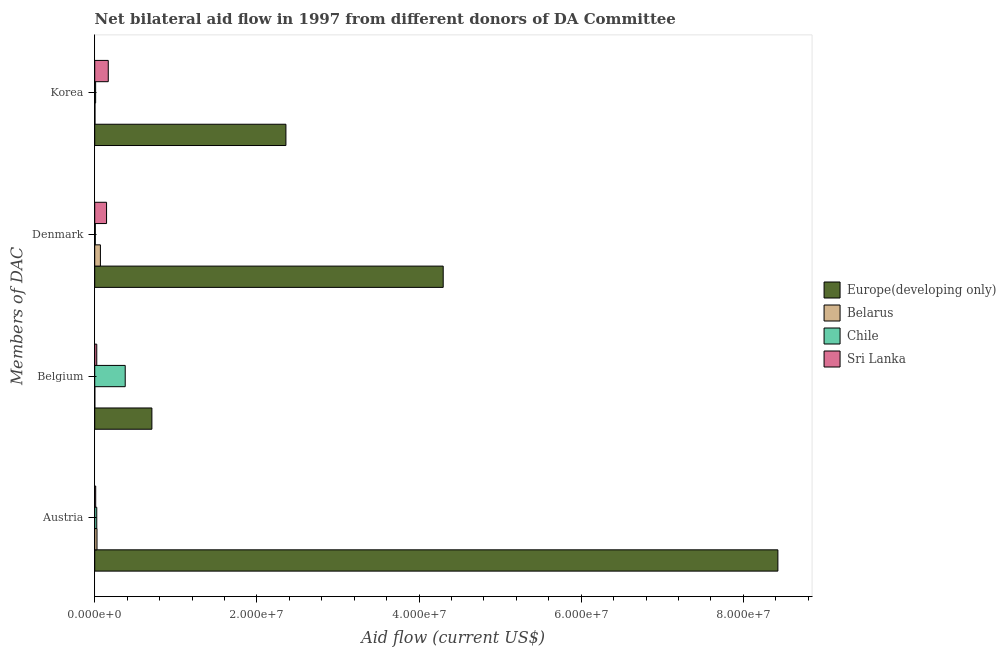How many groups of bars are there?
Offer a terse response. 4. Are the number of bars per tick equal to the number of legend labels?
Keep it short and to the point. Yes. What is the label of the 1st group of bars from the top?
Make the answer very short. Korea. What is the amount of aid given by korea in Sri Lanka?
Your answer should be very brief. 1.67e+06. Across all countries, what is the maximum amount of aid given by austria?
Make the answer very short. 8.43e+07. Across all countries, what is the minimum amount of aid given by denmark?
Ensure brevity in your answer.  7.00e+04. In which country was the amount of aid given by korea maximum?
Offer a terse response. Europe(developing only). In which country was the amount of aid given by denmark minimum?
Your answer should be compact. Chile. What is the total amount of aid given by denmark in the graph?
Provide a succinct answer. 4.52e+07. What is the difference between the amount of aid given by korea in Belarus and that in Chile?
Your response must be concise. -8.00e+04. What is the difference between the amount of aid given by austria in Europe(developing only) and the amount of aid given by belgium in Chile?
Offer a very short reply. 8.05e+07. What is the average amount of aid given by austria per country?
Ensure brevity in your answer.  2.12e+07. What is the difference between the amount of aid given by denmark and amount of aid given by austria in Europe(developing only)?
Your answer should be very brief. -4.13e+07. In how many countries, is the amount of aid given by austria greater than 48000000 US$?
Give a very brief answer. 1. What is the ratio of the amount of aid given by korea in Chile to that in Sri Lanka?
Your response must be concise. 0.07. Is the amount of aid given by austria in Chile less than that in Belarus?
Provide a succinct answer. Yes. Is the difference between the amount of aid given by korea in Europe(developing only) and Sri Lanka greater than the difference between the amount of aid given by belgium in Europe(developing only) and Sri Lanka?
Give a very brief answer. Yes. What is the difference between the highest and the second highest amount of aid given by denmark?
Provide a succinct answer. 4.15e+07. What is the difference between the highest and the lowest amount of aid given by denmark?
Provide a short and direct response. 4.29e+07. Is it the case that in every country, the sum of the amount of aid given by denmark and amount of aid given by belgium is greater than the sum of amount of aid given by korea and amount of aid given by austria?
Make the answer very short. No. What does the 2nd bar from the top in Austria represents?
Offer a very short reply. Chile. What does the 4th bar from the bottom in Belgium represents?
Offer a very short reply. Sri Lanka. How many bars are there?
Provide a succinct answer. 16. What is the difference between two consecutive major ticks on the X-axis?
Provide a succinct answer. 2.00e+07. How many legend labels are there?
Your answer should be compact. 4. How are the legend labels stacked?
Provide a succinct answer. Vertical. What is the title of the graph?
Your answer should be compact. Net bilateral aid flow in 1997 from different donors of DA Committee. Does "Hong Kong" appear as one of the legend labels in the graph?
Offer a very short reply. No. What is the label or title of the X-axis?
Keep it short and to the point. Aid flow (current US$). What is the label or title of the Y-axis?
Keep it short and to the point. Members of DAC. What is the Aid flow (current US$) in Europe(developing only) in Austria?
Offer a very short reply. 8.43e+07. What is the Aid flow (current US$) of Belarus in Austria?
Offer a terse response. 2.80e+05. What is the Aid flow (current US$) of Sri Lanka in Austria?
Give a very brief answer. 1.20e+05. What is the Aid flow (current US$) of Europe(developing only) in Belgium?
Provide a succinct answer. 7.05e+06. What is the Aid flow (current US$) of Belarus in Belgium?
Keep it short and to the point. 10000. What is the Aid flow (current US$) of Chile in Belgium?
Give a very brief answer. 3.76e+06. What is the Aid flow (current US$) of Sri Lanka in Belgium?
Provide a succinct answer. 2.50e+05. What is the Aid flow (current US$) in Europe(developing only) in Denmark?
Your answer should be compact. 4.30e+07. What is the Aid flow (current US$) in Sri Lanka in Denmark?
Your response must be concise. 1.46e+06. What is the Aid flow (current US$) in Europe(developing only) in Korea?
Offer a terse response. 2.36e+07. What is the Aid flow (current US$) in Sri Lanka in Korea?
Provide a short and direct response. 1.67e+06. Across all Members of DAC, what is the maximum Aid flow (current US$) of Europe(developing only)?
Offer a terse response. 8.43e+07. Across all Members of DAC, what is the maximum Aid flow (current US$) in Chile?
Provide a short and direct response. 3.76e+06. Across all Members of DAC, what is the maximum Aid flow (current US$) in Sri Lanka?
Offer a terse response. 1.67e+06. Across all Members of DAC, what is the minimum Aid flow (current US$) of Europe(developing only)?
Your answer should be compact. 7.05e+06. Across all Members of DAC, what is the minimum Aid flow (current US$) in Belarus?
Your answer should be compact. 10000. Across all Members of DAC, what is the minimum Aid flow (current US$) in Chile?
Offer a very short reply. 7.00e+04. What is the total Aid flow (current US$) in Europe(developing only) in the graph?
Your answer should be very brief. 1.58e+08. What is the total Aid flow (current US$) in Belarus in the graph?
Make the answer very short. 1.02e+06. What is the total Aid flow (current US$) of Chile in the graph?
Give a very brief answer. 4.19e+06. What is the total Aid flow (current US$) in Sri Lanka in the graph?
Keep it short and to the point. 3.50e+06. What is the difference between the Aid flow (current US$) of Europe(developing only) in Austria and that in Belgium?
Offer a very short reply. 7.72e+07. What is the difference between the Aid flow (current US$) in Chile in Austria and that in Belgium?
Offer a terse response. -3.51e+06. What is the difference between the Aid flow (current US$) in Europe(developing only) in Austria and that in Denmark?
Provide a succinct answer. 4.13e+07. What is the difference between the Aid flow (current US$) in Belarus in Austria and that in Denmark?
Give a very brief answer. -4.20e+05. What is the difference between the Aid flow (current US$) in Chile in Austria and that in Denmark?
Provide a short and direct response. 1.80e+05. What is the difference between the Aid flow (current US$) in Sri Lanka in Austria and that in Denmark?
Offer a very short reply. -1.34e+06. What is the difference between the Aid flow (current US$) of Europe(developing only) in Austria and that in Korea?
Your answer should be compact. 6.07e+07. What is the difference between the Aid flow (current US$) in Belarus in Austria and that in Korea?
Your response must be concise. 2.50e+05. What is the difference between the Aid flow (current US$) in Chile in Austria and that in Korea?
Provide a short and direct response. 1.40e+05. What is the difference between the Aid flow (current US$) in Sri Lanka in Austria and that in Korea?
Your answer should be very brief. -1.55e+06. What is the difference between the Aid flow (current US$) in Europe(developing only) in Belgium and that in Denmark?
Your answer should be compact. -3.59e+07. What is the difference between the Aid flow (current US$) in Belarus in Belgium and that in Denmark?
Provide a short and direct response. -6.90e+05. What is the difference between the Aid flow (current US$) of Chile in Belgium and that in Denmark?
Make the answer very short. 3.69e+06. What is the difference between the Aid flow (current US$) of Sri Lanka in Belgium and that in Denmark?
Your answer should be very brief. -1.21e+06. What is the difference between the Aid flow (current US$) of Europe(developing only) in Belgium and that in Korea?
Keep it short and to the point. -1.65e+07. What is the difference between the Aid flow (current US$) in Chile in Belgium and that in Korea?
Your answer should be compact. 3.65e+06. What is the difference between the Aid flow (current US$) of Sri Lanka in Belgium and that in Korea?
Offer a very short reply. -1.42e+06. What is the difference between the Aid flow (current US$) of Europe(developing only) in Denmark and that in Korea?
Keep it short and to the point. 1.94e+07. What is the difference between the Aid flow (current US$) of Belarus in Denmark and that in Korea?
Provide a succinct answer. 6.70e+05. What is the difference between the Aid flow (current US$) of Chile in Denmark and that in Korea?
Ensure brevity in your answer.  -4.00e+04. What is the difference between the Aid flow (current US$) in Europe(developing only) in Austria and the Aid flow (current US$) in Belarus in Belgium?
Provide a succinct answer. 8.42e+07. What is the difference between the Aid flow (current US$) in Europe(developing only) in Austria and the Aid flow (current US$) in Chile in Belgium?
Provide a succinct answer. 8.05e+07. What is the difference between the Aid flow (current US$) of Europe(developing only) in Austria and the Aid flow (current US$) of Sri Lanka in Belgium?
Keep it short and to the point. 8.40e+07. What is the difference between the Aid flow (current US$) in Belarus in Austria and the Aid flow (current US$) in Chile in Belgium?
Make the answer very short. -3.48e+06. What is the difference between the Aid flow (current US$) of Europe(developing only) in Austria and the Aid flow (current US$) of Belarus in Denmark?
Your answer should be compact. 8.36e+07. What is the difference between the Aid flow (current US$) of Europe(developing only) in Austria and the Aid flow (current US$) of Chile in Denmark?
Keep it short and to the point. 8.42e+07. What is the difference between the Aid flow (current US$) in Europe(developing only) in Austria and the Aid flow (current US$) in Sri Lanka in Denmark?
Offer a terse response. 8.28e+07. What is the difference between the Aid flow (current US$) of Belarus in Austria and the Aid flow (current US$) of Chile in Denmark?
Your answer should be compact. 2.10e+05. What is the difference between the Aid flow (current US$) in Belarus in Austria and the Aid flow (current US$) in Sri Lanka in Denmark?
Ensure brevity in your answer.  -1.18e+06. What is the difference between the Aid flow (current US$) of Chile in Austria and the Aid flow (current US$) of Sri Lanka in Denmark?
Your answer should be very brief. -1.21e+06. What is the difference between the Aid flow (current US$) in Europe(developing only) in Austria and the Aid flow (current US$) in Belarus in Korea?
Your answer should be compact. 8.42e+07. What is the difference between the Aid flow (current US$) in Europe(developing only) in Austria and the Aid flow (current US$) in Chile in Korea?
Provide a short and direct response. 8.42e+07. What is the difference between the Aid flow (current US$) in Europe(developing only) in Austria and the Aid flow (current US$) in Sri Lanka in Korea?
Provide a succinct answer. 8.26e+07. What is the difference between the Aid flow (current US$) of Belarus in Austria and the Aid flow (current US$) of Sri Lanka in Korea?
Provide a succinct answer. -1.39e+06. What is the difference between the Aid flow (current US$) in Chile in Austria and the Aid flow (current US$) in Sri Lanka in Korea?
Provide a succinct answer. -1.42e+06. What is the difference between the Aid flow (current US$) in Europe(developing only) in Belgium and the Aid flow (current US$) in Belarus in Denmark?
Ensure brevity in your answer.  6.35e+06. What is the difference between the Aid flow (current US$) of Europe(developing only) in Belgium and the Aid flow (current US$) of Chile in Denmark?
Offer a very short reply. 6.98e+06. What is the difference between the Aid flow (current US$) of Europe(developing only) in Belgium and the Aid flow (current US$) of Sri Lanka in Denmark?
Ensure brevity in your answer.  5.59e+06. What is the difference between the Aid flow (current US$) in Belarus in Belgium and the Aid flow (current US$) in Sri Lanka in Denmark?
Provide a short and direct response. -1.45e+06. What is the difference between the Aid flow (current US$) of Chile in Belgium and the Aid flow (current US$) of Sri Lanka in Denmark?
Offer a terse response. 2.30e+06. What is the difference between the Aid flow (current US$) of Europe(developing only) in Belgium and the Aid flow (current US$) of Belarus in Korea?
Your answer should be very brief. 7.02e+06. What is the difference between the Aid flow (current US$) in Europe(developing only) in Belgium and the Aid flow (current US$) in Chile in Korea?
Offer a terse response. 6.94e+06. What is the difference between the Aid flow (current US$) of Europe(developing only) in Belgium and the Aid flow (current US$) of Sri Lanka in Korea?
Ensure brevity in your answer.  5.38e+06. What is the difference between the Aid flow (current US$) in Belarus in Belgium and the Aid flow (current US$) in Sri Lanka in Korea?
Your response must be concise. -1.66e+06. What is the difference between the Aid flow (current US$) of Chile in Belgium and the Aid flow (current US$) of Sri Lanka in Korea?
Keep it short and to the point. 2.09e+06. What is the difference between the Aid flow (current US$) of Europe(developing only) in Denmark and the Aid flow (current US$) of Belarus in Korea?
Your answer should be compact. 4.30e+07. What is the difference between the Aid flow (current US$) of Europe(developing only) in Denmark and the Aid flow (current US$) of Chile in Korea?
Offer a very short reply. 4.29e+07. What is the difference between the Aid flow (current US$) of Europe(developing only) in Denmark and the Aid flow (current US$) of Sri Lanka in Korea?
Provide a short and direct response. 4.13e+07. What is the difference between the Aid flow (current US$) in Belarus in Denmark and the Aid flow (current US$) in Chile in Korea?
Give a very brief answer. 5.90e+05. What is the difference between the Aid flow (current US$) of Belarus in Denmark and the Aid flow (current US$) of Sri Lanka in Korea?
Offer a very short reply. -9.70e+05. What is the difference between the Aid flow (current US$) in Chile in Denmark and the Aid flow (current US$) in Sri Lanka in Korea?
Provide a succinct answer. -1.60e+06. What is the average Aid flow (current US$) of Europe(developing only) per Members of DAC?
Make the answer very short. 3.95e+07. What is the average Aid flow (current US$) of Belarus per Members of DAC?
Make the answer very short. 2.55e+05. What is the average Aid flow (current US$) of Chile per Members of DAC?
Offer a terse response. 1.05e+06. What is the average Aid flow (current US$) of Sri Lanka per Members of DAC?
Your answer should be compact. 8.75e+05. What is the difference between the Aid flow (current US$) of Europe(developing only) and Aid flow (current US$) of Belarus in Austria?
Provide a short and direct response. 8.40e+07. What is the difference between the Aid flow (current US$) of Europe(developing only) and Aid flow (current US$) of Chile in Austria?
Provide a succinct answer. 8.40e+07. What is the difference between the Aid flow (current US$) of Europe(developing only) and Aid flow (current US$) of Sri Lanka in Austria?
Make the answer very short. 8.41e+07. What is the difference between the Aid flow (current US$) of Chile and Aid flow (current US$) of Sri Lanka in Austria?
Ensure brevity in your answer.  1.30e+05. What is the difference between the Aid flow (current US$) in Europe(developing only) and Aid flow (current US$) in Belarus in Belgium?
Give a very brief answer. 7.04e+06. What is the difference between the Aid flow (current US$) of Europe(developing only) and Aid flow (current US$) of Chile in Belgium?
Provide a short and direct response. 3.29e+06. What is the difference between the Aid flow (current US$) of Europe(developing only) and Aid flow (current US$) of Sri Lanka in Belgium?
Your answer should be compact. 6.80e+06. What is the difference between the Aid flow (current US$) of Belarus and Aid flow (current US$) of Chile in Belgium?
Keep it short and to the point. -3.75e+06. What is the difference between the Aid flow (current US$) of Chile and Aid flow (current US$) of Sri Lanka in Belgium?
Provide a short and direct response. 3.51e+06. What is the difference between the Aid flow (current US$) in Europe(developing only) and Aid flow (current US$) in Belarus in Denmark?
Keep it short and to the point. 4.23e+07. What is the difference between the Aid flow (current US$) of Europe(developing only) and Aid flow (current US$) of Chile in Denmark?
Offer a very short reply. 4.29e+07. What is the difference between the Aid flow (current US$) in Europe(developing only) and Aid flow (current US$) in Sri Lanka in Denmark?
Ensure brevity in your answer.  4.15e+07. What is the difference between the Aid flow (current US$) in Belarus and Aid flow (current US$) in Chile in Denmark?
Provide a short and direct response. 6.30e+05. What is the difference between the Aid flow (current US$) in Belarus and Aid flow (current US$) in Sri Lanka in Denmark?
Ensure brevity in your answer.  -7.60e+05. What is the difference between the Aid flow (current US$) in Chile and Aid flow (current US$) in Sri Lanka in Denmark?
Give a very brief answer. -1.39e+06. What is the difference between the Aid flow (current US$) of Europe(developing only) and Aid flow (current US$) of Belarus in Korea?
Your answer should be very brief. 2.36e+07. What is the difference between the Aid flow (current US$) in Europe(developing only) and Aid flow (current US$) in Chile in Korea?
Give a very brief answer. 2.35e+07. What is the difference between the Aid flow (current US$) in Europe(developing only) and Aid flow (current US$) in Sri Lanka in Korea?
Your answer should be compact. 2.19e+07. What is the difference between the Aid flow (current US$) in Belarus and Aid flow (current US$) in Chile in Korea?
Your answer should be very brief. -8.00e+04. What is the difference between the Aid flow (current US$) of Belarus and Aid flow (current US$) of Sri Lanka in Korea?
Your response must be concise. -1.64e+06. What is the difference between the Aid flow (current US$) of Chile and Aid flow (current US$) of Sri Lanka in Korea?
Your answer should be very brief. -1.56e+06. What is the ratio of the Aid flow (current US$) of Europe(developing only) in Austria to that in Belgium?
Offer a very short reply. 11.95. What is the ratio of the Aid flow (current US$) of Chile in Austria to that in Belgium?
Ensure brevity in your answer.  0.07. What is the ratio of the Aid flow (current US$) in Sri Lanka in Austria to that in Belgium?
Make the answer very short. 0.48. What is the ratio of the Aid flow (current US$) in Europe(developing only) in Austria to that in Denmark?
Offer a very short reply. 1.96. What is the ratio of the Aid flow (current US$) of Belarus in Austria to that in Denmark?
Your response must be concise. 0.4. What is the ratio of the Aid flow (current US$) in Chile in Austria to that in Denmark?
Offer a terse response. 3.57. What is the ratio of the Aid flow (current US$) in Sri Lanka in Austria to that in Denmark?
Offer a terse response. 0.08. What is the ratio of the Aid flow (current US$) of Europe(developing only) in Austria to that in Korea?
Keep it short and to the point. 3.57. What is the ratio of the Aid flow (current US$) in Belarus in Austria to that in Korea?
Your answer should be compact. 9.33. What is the ratio of the Aid flow (current US$) of Chile in Austria to that in Korea?
Your answer should be compact. 2.27. What is the ratio of the Aid flow (current US$) of Sri Lanka in Austria to that in Korea?
Ensure brevity in your answer.  0.07. What is the ratio of the Aid flow (current US$) of Europe(developing only) in Belgium to that in Denmark?
Give a very brief answer. 0.16. What is the ratio of the Aid flow (current US$) of Belarus in Belgium to that in Denmark?
Give a very brief answer. 0.01. What is the ratio of the Aid flow (current US$) of Chile in Belgium to that in Denmark?
Your response must be concise. 53.71. What is the ratio of the Aid flow (current US$) of Sri Lanka in Belgium to that in Denmark?
Keep it short and to the point. 0.17. What is the ratio of the Aid flow (current US$) of Europe(developing only) in Belgium to that in Korea?
Offer a terse response. 0.3. What is the ratio of the Aid flow (current US$) of Chile in Belgium to that in Korea?
Your answer should be very brief. 34.18. What is the ratio of the Aid flow (current US$) of Sri Lanka in Belgium to that in Korea?
Keep it short and to the point. 0.15. What is the ratio of the Aid flow (current US$) of Europe(developing only) in Denmark to that in Korea?
Keep it short and to the point. 1.82. What is the ratio of the Aid flow (current US$) of Belarus in Denmark to that in Korea?
Your answer should be very brief. 23.33. What is the ratio of the Aid flow (current US$) in Chile in Denmark to that in Korea?
Your answer should be compact. 0.64. What is the ratio of the Aid flow (current US$) of Sri Lanka in Denmark to that in Korea?
Ensure brevity in your answer.  0.87. What is the difference between the highest and the second highest Aid flow (current US$) in Europe(developing only)?
Offer a very short reply. 4.13e+07. What is the difference between the highest and the second highest Aid flow (current US$) in Belarus?
Your response must be concise. 4.20e+05. What is the difference between the highest and the second highest Aid flow (current US$) of Chile?
Keep it short and to the point. 3.51e+06. What is the difference between the highest and the second highest Aid flow (current US$) in Sri Lanka?
Ensure brevity in your answer.  2.10e+05. What is the difference between the highest and the lowest Aid flow (current US$) in Europe(developing only)?
Your answer should be compact. 7.72e+07. What is the difference between the highest and the lowest Aid flow (current US$) of Belarus?
Keep it short and to the point. 6.90e+05. What is the difference between the highest and the lowest Aid flow (current US$) of Chile?
Offer a terse response. 3.69e+06. What is the difference between the highest and the lowest Aid flow (current US$) of Sri Lanka?
Your answer should be very brief. 1.55e+06. 